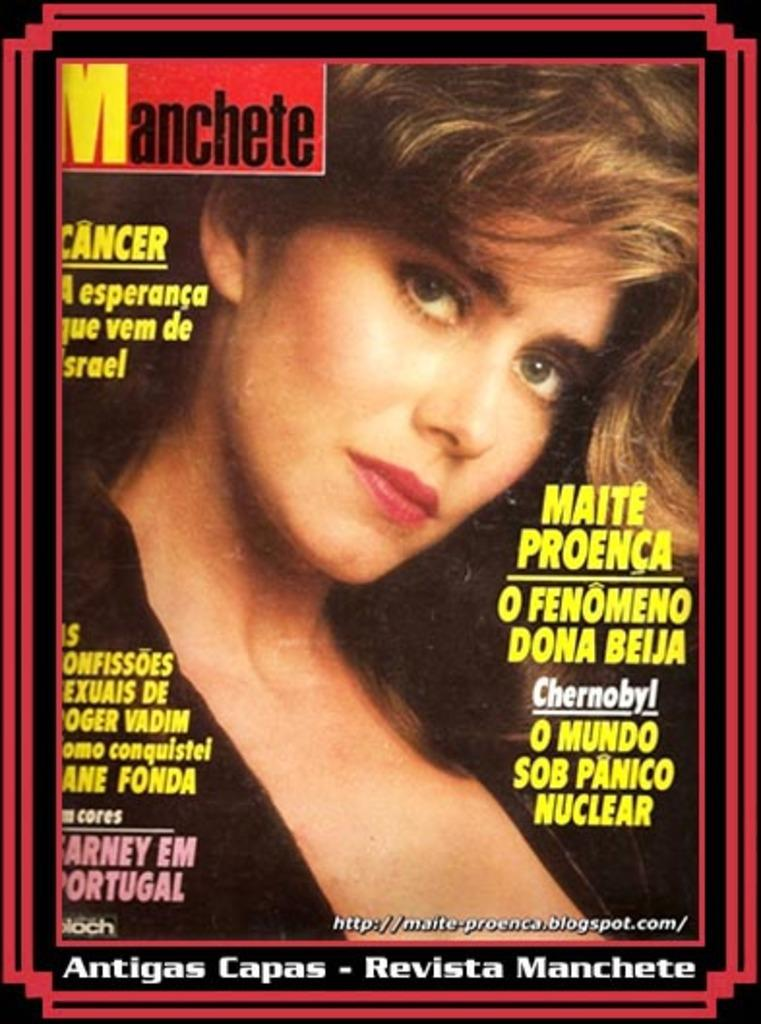What is present in the image that features a design or message? There is a poster in the image. What is depicted on the poster? The poster features a woman. What else can be found on the poster besides the image? There is text written on the poster. What type of store can be seen in the background of the image? There is no store present in the image; it only features a poster with a woman and text. What type of school is depicted in the image? There is no school present in the image; it only features a poster with a woman and text. 